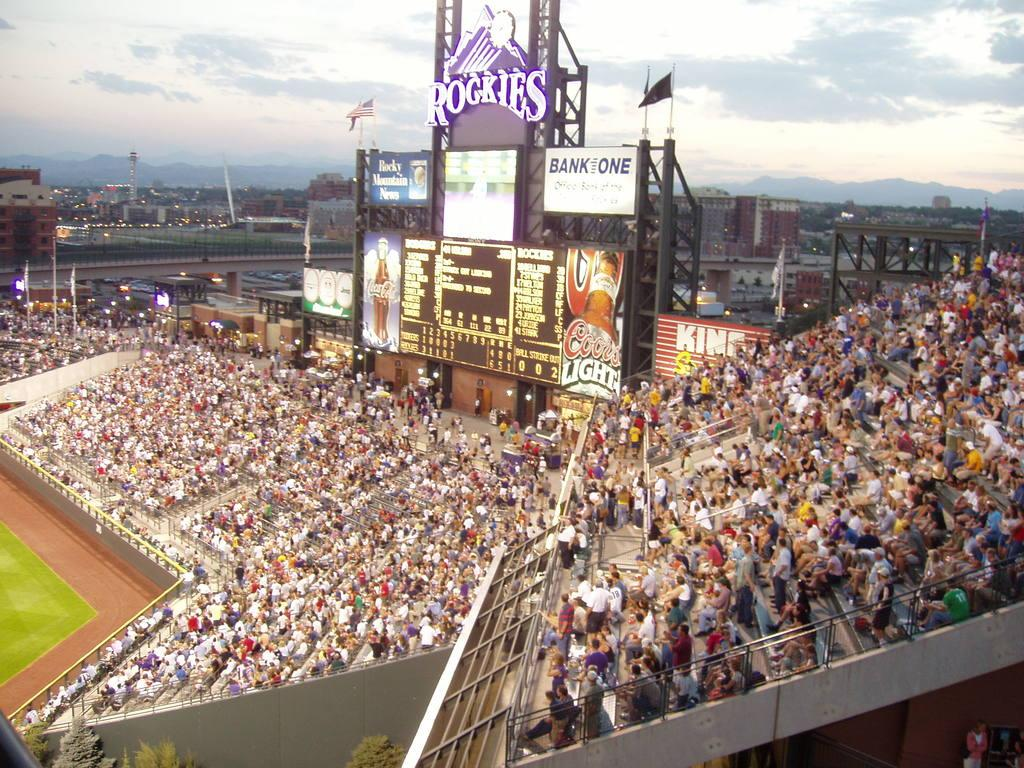<image>
Write a terse but informative summary of the picture. the name Rockies is at the top of the stadium 